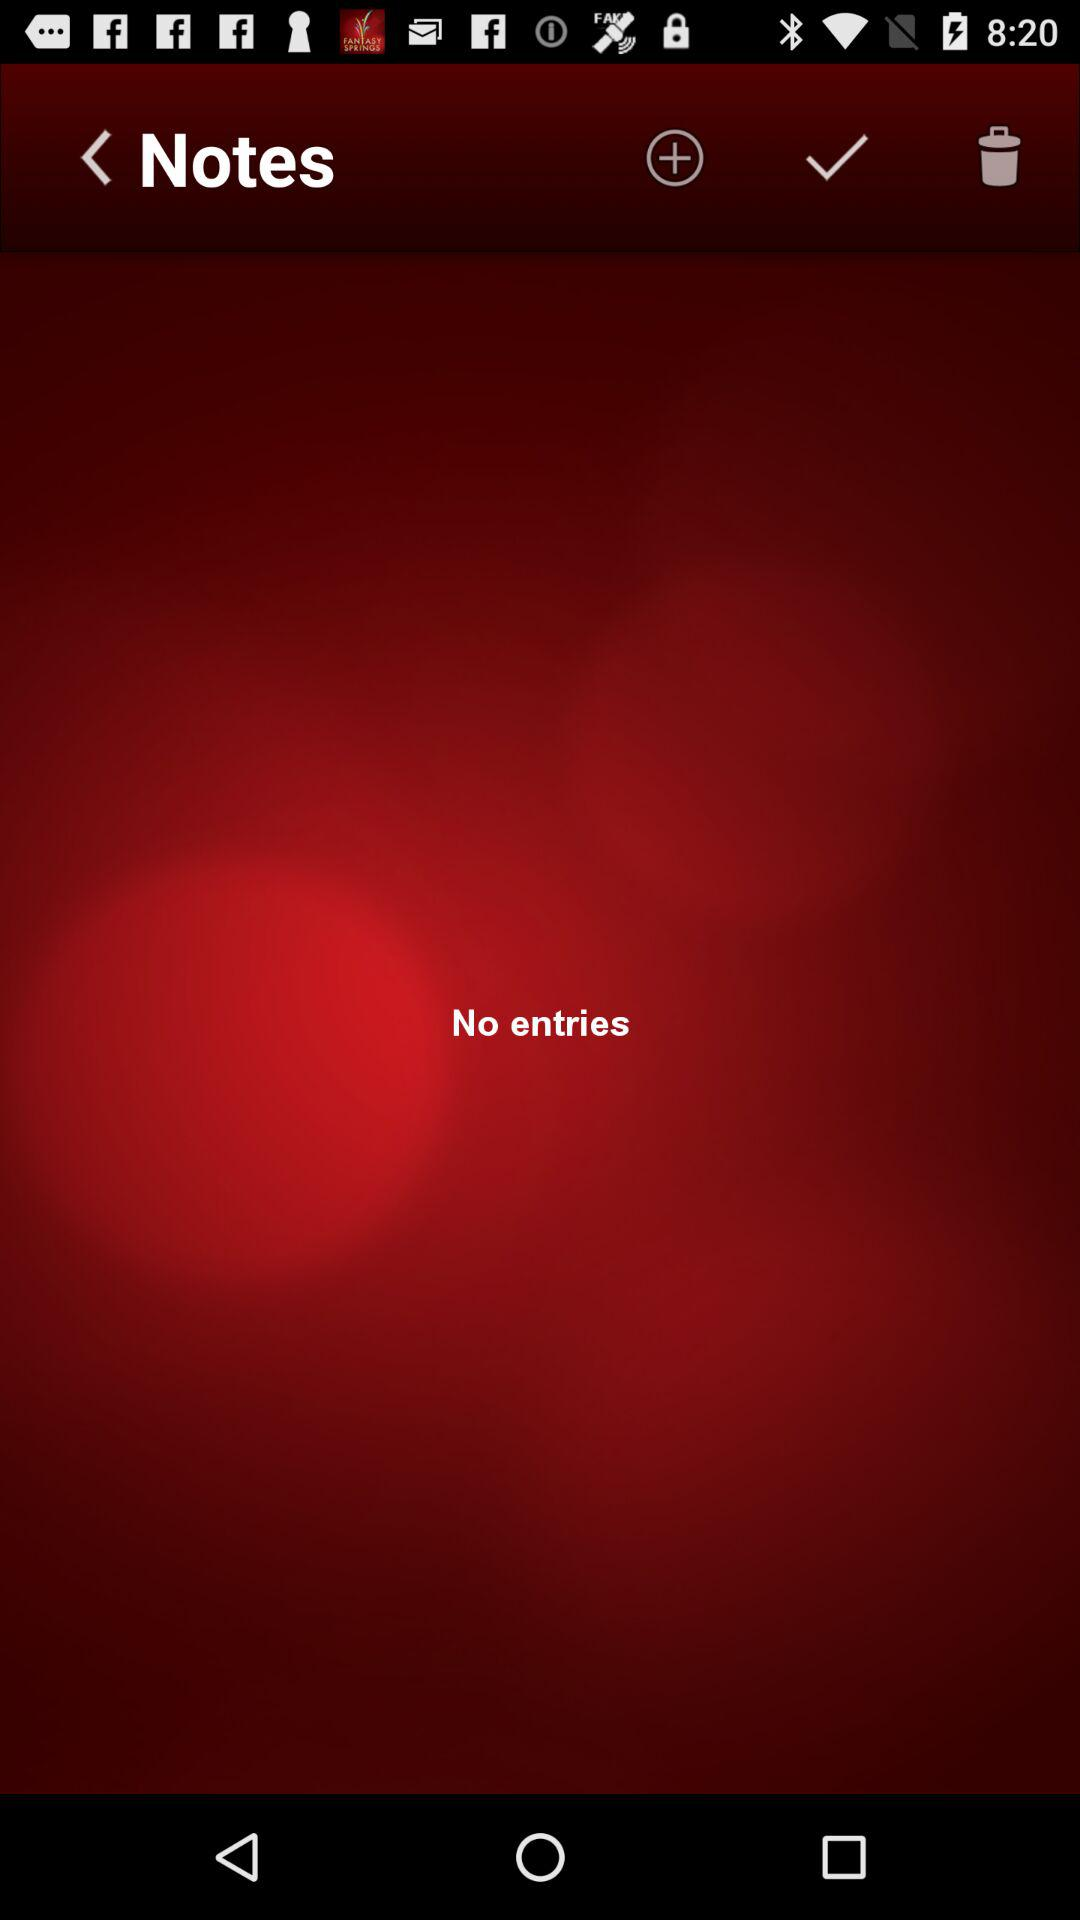How many entries are there? There are no entries. 